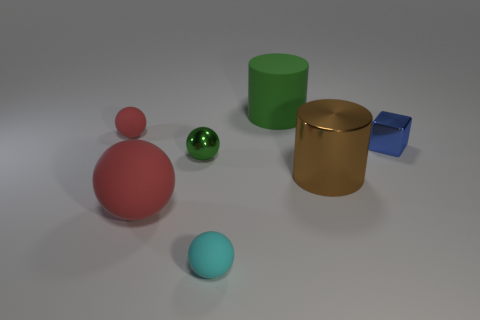Add 1 green rubber cylinders. How many objects exist? 8 Subtract all rubber balls. How many balls are left? 1 Subtract all cyan spheres. How many spheres are left? 3 Subtract 2 cylinders. How many cylinders are left? 0 Add 2 small blue metallic things. How many small blue metallic things are left? 3 Add 3 tiny cyan things. How many tiny cyan things exist? 4 Subtract 1 blue cubes. How many objects are left? 6 Subtract all cubes. How many objects are left? 6 Subtract all cyan cubes. Subtract all cyan cylinders. How many cubes are left? 1 Subtract all gray spheres. How many green cylinders are left? 1 